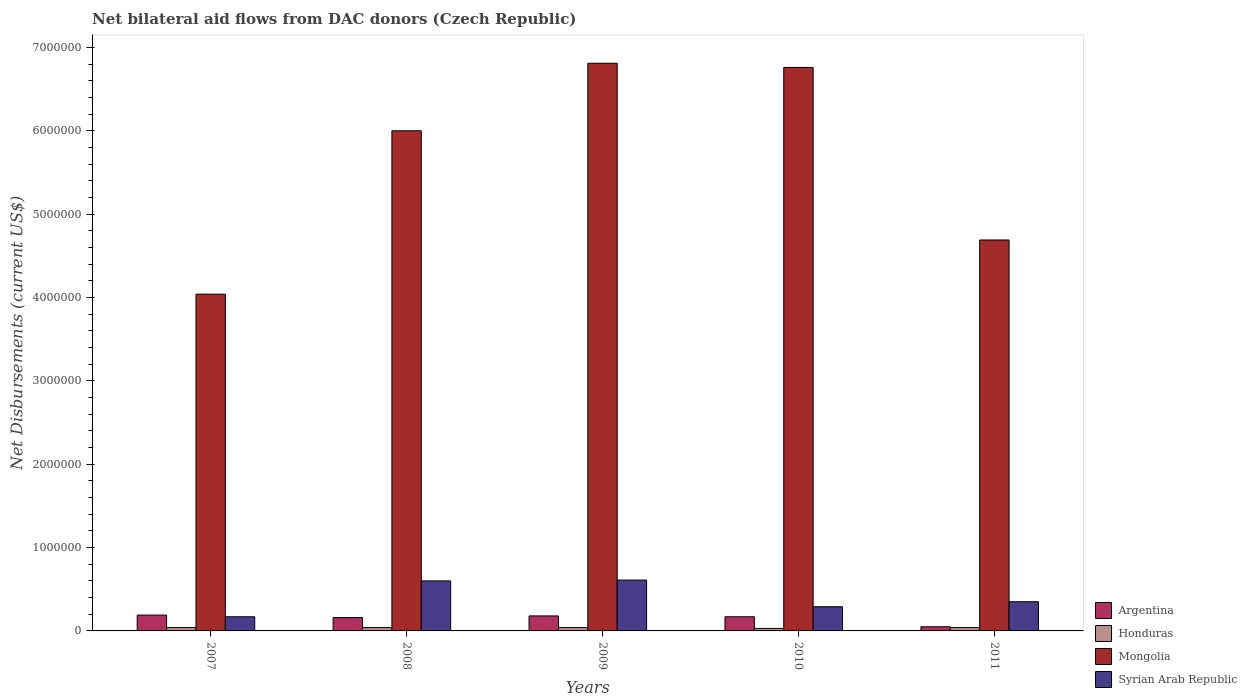How many different coloured bars are there?
Offer a very short reply. 4. Are the number of bars on each tick of the X-axis equal?
Ensure brevity in your answer.  Yes. How many bars are there on the 4th tick from the left?
Keep it short and to the point. 4. How many bars are there on the 2nd tick from the right?
Your answer should be compact. 4. What is the label of the 4th group of bars from the left?
Provide a succinct answer. 2010. In how many cases, is the number of bars for a given year not equal to the number of legend labels?
Give a very brief answer. 0. What is the net bilateral aid flows in Mongolia in 2010?
Make the answer very short. 6.76e+06. Across all years, what is the maximum net bilateral aid flows in Syrian Arab Republic?
Provide a short and direct response. 6.10e+05. Across all years, what is the minimum net bilateral aid flows in Honduras?
Make the answer very short. 3.00e+04. In which year was the net bilateral aid flows in Argentina minimum?
Your response must be concise. 2011. What is the total net bilateral aid flows in Syrian Arab Republic in the graph?
Your answer should be very brief. 2.02e+06. What is the difference between the net bilateral aid flows in Argentina in 2007 and that in 2011?
Give a very brief answer. 1.40e+05. What is the difference between the net bilateral aid flows in Mongolia in 2010 and the net bilateral aid flows in Honduras in 2009?
Your answer should be compact. 6.72e+06. What is the average net bilateral aid flows in Syrian Arab Republic per year?
Ensure brevity in your answer.  4.04e+05. In the year 2010, what is the difference between the net bilateral aid flows in Mongolia and net bilateral aid flows in Syrian Arab Republic?
Provide a succinct answer. 6.47e+06. In how many years, is the net bilateral aid flows in Mongolia greater than 2400000 US$?
Your response must be concise. 5. What is the ratio of the net bilateral aid flows in Honduras in 2008 to that in 2011?
Give a very brief answer. 1. Is the net bilateral aid flows in Argentina in 2007 less than that in 2009?
Ensure brevity in your answer.  No. What is the difference between the highest and the lowest net bilateral aid flows in Syrian Arab Republic?
Offer a very short reply. 4.40e+05. What does the 4th bar from the left in 2010 represents?
Provide a succinct answer. Syrian Arab Republic. What does the 2nd bar from the right in 2011 represents?
Give a very brief answer. Mongolia. How many bars are there?
Keep it short and to the point. 20. Are all the bars in the graph horizontal?
Provide a short and direct response. No. How many years are there in the graph?
Offer a terse response. 5. What is the difference between two consecutive major ticks on the Y-axis?
Ensure brevity in your answer.  1.00e+06. Does the graph contain grids?
Make the answer very short. No. How many legend labels are there?
Ensure brevity in your answer.  4. What is the title of the graph?
Provide a succinct answer. Net bilateral aid flows from DAC donors (Czech Republic). Does "Middle East & North Africa (developing only)" appear as one of the legend labels in the graph?
Keep it short and to the point. No. What is the label or title of the X-axis?
Your answer should be compact. Years. What is the label or title of the Y-axis?
Your answer should be compact. Net Disbursements (current US$). What is the Net Disbursements (current US$) in Argentina in 2007?
Make the answer very short. 1.90e+05. What is the Net Disbursements (current US$) in Mongolia in 2007?
Give a very brief answer. 4.04e+06. What is the Net Disbursements (current US$) of Syrian Arab Republic in 2007?
Offer a terse response. 1.70e+05. What is the Net Disbursements (current US$) in Argentina in 2008?
Ensure brevity in your answer.  1.60e+05. What is the Net Disbursements (current US$) of Honduras in 2009?
Give a very brief answer. 4.00e+04. What is the Net Disbursements (current US$) of Mongolia in 2009?
Your answer should be compact. 6.81e+06. What is the Net Disbursements (current US$) in Syrian Arab Republic in 2009?
Provide a succinct answer. 6.10e+05. What is the Net Disbursements (current US$) of Argentina in 2010?
Give a very brief answer. 1.70e+05. What is the Net Disbursements (current US$) in Mongolia in 2010?
Offer a very short reply. 6.76e+06. What is the Net Disbursements (current US$) in Syrian Arab Republic in 2010?
Provide a succinct answer. 2.90e+05. What is the Net Disbursements (current US$) of Mongolia in 2011?
Provide a succinct answer. 4.69e+06. What is the Net Disbursements (current US$) of Syrian Arab Republic in 2011?
Offer a very short reply. 3.50e+05. Across all years, what is the maximum Net Disbursements (current US$) of Mongolia?
Your response must be concise. 6.81e+06. Across all years, what is the minimum Net Disbursements (current US$) in Argentina?
Offer a terse response. 5.00e+04. Across all years, what is the minimum Net Disbursements (current US$) of Mongolia?
Keep it short and to the point. 4.04e+06. Across all years, what is the minimum Net Disbursements (current US$) of Syrian Arab Republic?
Make the answer very short. 1.70e+05. What is the total Net Disbursements (current US$) in Argentina in the graph?
Your response must be concise. 7.50e+05. What is the total Net Disbursements (current US$) of Mongolia in the graph?
Your answer should be compact. 2.83e+07. What is the total Net Disbursements (current US$) in Syrian Arab Republic in the graph?
Offer a terse response. 2.02e+06. What is the difference between the Net Disbursements (current US$) of Argentina in 2007 and that in 2008?
Your answer should be compact. 3.00e+04. What is the difference between the Net Disbursements (current US$) in Honduras in 2007 and that in 2008?
Provide a succinct answer. 0. What is the difference between the Net Disbursements (current US$) of Mongolia in 2007 and that in 2008?
Your answer should be compact. -1.96e+06. What is the difference between the Net Disbursements (current US$) in Syrian Arab Republic in 2007 and that in 2008?
Keep it short and to the point. -4.30e+05. What is the difference between the Net Disbursements (current US$) in Honduras in 2007 and that in 2009?
Keep it short and to the point. 0. What is the difference between the Net Disbursements (current US$) in Mongolia in 2007 and that in 2009?
Give a very brief answer. -2.77e+06. What is the difference between the Net Disbursements (current US$) in Syrian Arab Republic in 2007 and that in 2009?
Give a very brief answer. -4.40e+05. What is the difference between the Net Disbursements (current US$) of Mongolia in 2007 and that in 2010?
Provide a short and direct response. -2.72e+06. What is the difference between the Net Disbursements (current US$) of Argentina in 2007 and that in 2011?
Provide a short and direct response. 1.40e+05. What is the difference between the Net Disbursements (current US$) in Honduras in 2007 and that in 2011?
Provide a short and direct response. 0. What is the difference between the Net Disbursements (current US$) in Mongolia in 2007 and that in 2011?
Ensure brevity in your answer.  -6.50e+05. What is the difference between the Net Disbursements (current US$) of Argentina in 2008 and that in 2009?
Your response must be concise. -2.00e+04. What is the difference between the Net Disbursements (current US$) of Mongolia in 2008 and that in 2009?
Your answer should be compact. -8.10e+05. What is the difference between the Net Disbursements (current US$) in Mongolia in 2008 and that in 2010?
Your answer should be compact. -7.60e+05. What is the difference between the Net Disbursements (current US$) in Mongolia in 2008 and that in 2011?
Provide a succinct answer. 1.31e+06. What is the difference between the Net Disbursements (current US$) of Honduras in 2009 and that in 2010?
Offer a terse response. 10000. What is the difference between the Net Disbursements (current US$) of Mongolia in 2009 and that in 2010?
Your answer should be compact. 5.00e+04. What is the difference between the Net Disbursements (current US$) in Syrian Arab Republic in 2009 and that in 2010?
Give a very brief answer. 3.20e+05. What is the difference between the Net Disbursements (current US$) in Honduras in 2009 and that in 2011?
Make the answer very short. 0. What is the difference between the Net Disbursements (current US$) in Mongolia in 2009 and that in 2011?
Your answer should be compact. 2.12e+06. What is the difference between the Net Disbursements (current US$) of Syrian Arab Republic in 2009 and that in 2011?
Make the answer very short. 2.60e+05. What is the difference between the Net Disbursements (current US$) in Honduras in 2010 and that in 2011?
Offer a terse response. -10000. What is the difference between the Net Disbursements (current US$) in Mongolia in 2010 and that in 2011?
Provide a short and direct response. 2.07e+06. What is the difference between the Net Disbursements (current US$) of Syrian Arab Republic in 2010 and that in 2011?
Provide a short and direct response. -6.00e+04. What is the difference between the Net Disbursements (current US$) in Argentina in 2007 and the Net Disbursements (current US$) in Honduras in 2008?
Offer a terse response. 1.50e+05. What is the difference between the Net Disbursements (current US$) of Argentina in 2007 and the Net Disbursements (current US$) of Mongolia in 2008?
Provide a short and direct response. -5.81e+06. What is the difference between the Net Disbursements (current US$) of Argentina in 2007 and the Net Disbursements (current US$) of Syrian Arab Republic in 2008?
Provide a succinct answer. -4.10e+05. What is the difference between the Net Disbursements (current US$) in Honduras in 2007 and the Net Disbursements (current US$) in Mongolia in 2008?
Offer a terse response. -5.96e+06. What is the difference between the Net Disbursements (current US$) of Honduras in 2007 and the Net Disbursements (current US$) of Syrian Arab Republic in 2008?
Your answer should be very brief. -5.60e+05. What is the difference between the Net Disbursements (current US$) in Mongolia in 2007 and the Net Disbursements (current US$) in Syrian Arab Republic in 2008?
Keep it short and to the point. 3.44e+06. What is the difference between the Net Disbursements (current US$) in Argentina in 2007 and the Net Disbursements (current US$) in Mongolia in 2009?
Offer a very short reply. -6.62e+06. What is the difference between the Net Disbursements (current US$) in Argentina in 2007 and the Net Disbursements (current US$) in Syrian Arab Republic in 2009?
Offer a terse response. -4.20e+05. What is the difference between the Net Disbursements (current US$) of Honduras in 2007 and the Net Disbursements (current US$) of Mongolia in 2009?
Your answer should be very brief. -6.77e+06. What is the difference between the Net Disbursements (current US$) in Honduras in 2007 and the Net Disbursements (current US$) in Syrian Arab Republic in 2009?
Provide a short and direct response. -5.70e+05. What is the difference between the Net Disbursements (current US$) in Mongolia in 2007 and the Net Disbursements (current US$) in Syrian Arab Republic in 2009?
Your response must be concise. 3.43e+06. What is the difference between the Net Disbursements (current US$) in Argentina in 2007 and the Net Disbursements (current US$) in Mongolia in 2010?
Your response must be concise. -6.57e+06. What is the difference between the Net Disbursements (current US$) of Honduras in 2007 and the Net Disbursements (current US$) of Mongolia in 2010?
Keep it short and to the point. -6.72e+06. What is the difference between the Net Disbursements (current US$) of Honduras in 2007 and the Net Disbursements (current US$) of Syrian Arab Republic in 2010?
Give a very brief answer. -2.50e+05. What is the difference between the Net Disbursements (current US$) of Mongolia in 2007 and the Net Disbursements (current US$) of Syrian Arab Republic in 2010?
Keep it short and to the point. 3.75e+06. What is the difference between the Net Disbursements (current US$) in Argentina in 2007 and the Net Disbursements (current US$) in Mongolia in 2011?
Your response must be concise. -4.50e+06. What is the difference between the Net Disbursements (current US$) of Honduras in 2007 and the Net Disbursements (current US$) of Mongolia in 2011?
Offer a very short reply. -4.65e+06. What is the difference between the Net Disbursements (current US$) in Honduras in 2007 and the Net Disbursements (current US$) in Syrian Arab Republic in 2011?
Make the answer very short. -3.10e+05. What is the difference between the Net Disbursements (current US$) in Mongolia in 2007 and the Net Disbursements (current US$) in Syrian Arab Republic in 2011?
Give a very brief answer. 3.69e+06. What is the difference between the Net Disbursements (current US$) of Argentina in 2008 and the Net Disbursements (current US$) of Honduras in 2009?
Your response must be concise. 1.20e+05. What is the difference between the Net Disbursements (current US$) in Argentina in 2008 and the Net Disbursements (current US$) in Mongolia in 2009?
Offer a very short reply. -6.65e+06. What is the difference between the Net Disbursements (current US$) of Argentina in 2008 and the Net Disbursements (current US$) of Syrian Arab Republic in 2009?
Give a very brief answer. -4.50e+05. What is the difference between the Net Disbursements (current US$) of Honduras in 2008 and the Net Disbursements (current US$) of Mongolia in 2009?
Your answer should be compact. -6.77e+06. What is the difference between the Net Disbursements (current US$) in Honduras in 2008 and the Net Disbursements (current US$) in Syrian Arab Republic in 2009?
Keep it short and to the point. -5.70e+05. What is the difference between the Net Disbursements (current US$) in Mongolia in 2008 and the Net Disbursements (current US$) in Syrian Arab Republic in 2009?
Ensure brevity in your answer.  5.39e+06. What is the difference between the Net Disbursements (current US$) in Argentina in 2008 and the Net Disbursements (current US$) in Honduras in 2010?
Offer a very short reply. 1.30e+05. What is the difference between the Net Disbursements (current US$) in Argentina in 2008 and the Net Disbursements (current US$) in Mongolia in 2010?
Provide a succinct answer. -6.60e+06. What is the difference between the Net Disbursements (current US$) in Honduras in 2008 and the Net Disbursements (current US$) in Mongolia in 2010?
Your response must be concise. -6.72e+06. What is the difference between the Net Disbursements (current US$) of Mongolia in 2008 and the Net Disbursements (current US$) of Syrian Arab Republic in 2010?
Give a very brief answer. 5.71e+06. What is the difference between the Net Disbursements (current US$) in Argentina in 2008 and the Net Disbursements (current US$) in Honduras in 2011?
Offer a terse response. 1.20e+05. What is the difference between the Net Disbursements (current US$) in Argentina in 2008 and the Net Disbursements (current US$) in Mongolia in 2011?
Make the answer very short. -4.53e+06. What is the difference between the Net Disbursements (current US$) of Honduras in 2008 and the Net Disbursements (current US$) of Mongolia in 2011?
Your answer should be very brief. -4.65e+06. What is the difference between the Net Disbursements (current US$) in Honduras in 2008 and the Net Disbursements (current US$) in Syrian Arab Republic in 2011?
Offer a terse response. -3.10e+05. What is the difference between the Net Disbursements (current US$) in Mongolia in 2008 and the Net Disbursements (current US$) in Syrian Arab Republic in 2011?
Provide a short and direct response. 5.65e+06. What is the difference between the Net Disbursements (current US$) of Argentina in 2009 and the Net Disbursements (current US$) of Honduras in 2010?
Ensure brevity in your answer.  1.50e+05. What is the difference between the Net Disbursements (current US$) of Argentina in 2009 and the Net Disbursements (current US$) of Mongolia in 2010?
Your answer should be very brief. -6.58e+06. What is the difference between the Net Disbursements (current US$) in Argentina in 2009 and the Net Disbursements (current US$) in Syrian Arab Republic in 2010?
Offer a terse response. -1.10e+05. What is the difference between the Net Disbursements (current US$) of Honduras in 2009 and the Net Disbursements (current US$) of Mongolia in 2010?
Your answer should be compact. -6.72e+06. What is the difference between the Net Disbursements (current US$) of Honduras in 2009 and the Net Disbursements (current US$) of Syrian Arab Republic in 2010?
Provide a short and direct response. -2.50e+05. What is the difference between the Net Disbursements (current US$) in Mongolia in 2009 and the Net Disbursements (current US$) in Syrian Arab Republic in 2010?
Give a very brief answer. 6.52e+06. What is the difference between the Net Disbursements (current US$) of Argentina in 2009 and the Net Disbursements (current US$) of Honduras in 2011?
Your response must be concise. 1.40e+05. What is the difference between the Net Disbursements (current US$) of Argentina in 2009 and the Net Disbursements (current US$) of Mongolia in 2011?
Make the answer very short. -4.51e+06. What is the difference between the Net Disbursements (current US$) of Argentina in 2009 and the Net Disbursements (current US$) of Syrian Arab Republic in 2011?
Keep it short and to the point. -1.70e+05. What is the difference between the Net Disbursements (current US$) in Honduras in 2009 and the Net Disbursements (current US$) in Mongolia in 2011?
Your answer should be compact. -4.65e+06. What is the difference between the Net Disbursements (current US$) of Honduras in 2009 and the Net Disbursements (current US$) of Syrian Arab Republic in 2011?
Give a very brief answer. -3.10e+05. What is the difference between the Net Disbursements (current US$) of Mongolia in 2009 and the Net Disbursements (current US$) of Syrian Arab Republic in 2011?
Your response must be concise. 6.46e+06. What is the difference between the Net Disbursements (current US$) in Argentina in 2010 and the Net Disbursements (current US$) in Mongolia in 2011?
Your answer should be compact. -4.52e+06. What is the difference between the Net Disbursements (current US$) in Argentina in 2010 and the Net Disbursements (current US$) in Syrian Arab Republic in 2011?
Keep it short and to the point. -1.80e+05. What is the difference between the Net Disbursements (current US$) of Honduras in 2010 and the Net Disbursements (current US$) of Mongolia in 2011?
Ensure brevity in your answer.  -4.66e+06. What is the difference between the Net Disbursements (current US$) of Honduras in 2010 and the Net Disbursements (current US$) of Syrian Arab Republic in 2011?
Make the answer very short. -3.20e+05. What is the difference between the Net Disbursements (current US$) of Mongolia in 2010 and the Net Disbursements (current US$) of Syrian Arab Republic in 2011?
Offer a terse response. 6.41e+06. What is the average Net Disbursements (current US$) in Argentina per year?
Give a very brief answer. 1.50e+05. What is the average Net Disbursements (current US$) of Honduras per year?
Offer a very short reply. 3.80e+04. What is the average Net Disbursements (current US$) of Mongolia per year?
Provide a short and direct response. 5.66e+06. What is the average Net Disbursements (current US$) of Syrian Arab Republic per year?
Keep it short and to the point. 4.04e+05. In the year 2007, what is the difference between the Net Disbursements (current US$) in Argentina and Net Disbursements (current US$) in Honduras?
Your answer should be very brief. 1.50e+05. In the year 2007, what is the difference between the Net Disbursements (current US$) of Argentina and Net Disbursements (current US$) of Mongolia?
Your answer should be very brief. -3.85e+06. In the year 2007, what is the difference between the Net Disbursements (current US$) of Honduras and Net Disbursements (current US$) of Mongolia?
Give a very brief answer. -4.00e+06. In the year 2007, what is the difference between the Net Disbursements (current US$) in Honduras and Net Disbursements (current US$) in Syrian Arab Republic?
Keep it short and to the point. -1.30e+05. In the year 2007, what is the difference between the Net Disbursements (current US$) in Mongolia and Net Disbursements (current US$) in Syrian Arab Republic?
Provide a short and direct response. 3.87e+06. In the year 2008, what is the difference between the Net Disbursements (current US$) of Argentina and Net Disbursements (current US$) of Mongolia?
Provide a succinct answer. -5.84e+06. In the year 2008, what is the difference between the Net Disbursements (current US$) in Argentina and Net Disbursements (current US$) in Syrian Arab Republic?
Offer a very short reply. -4.40e+05. In the year 2008, what is the difference between the Net Disbursements (current US$) of Honduras and Net Disbursements (current US$) of Mongolia?
Provide a short and direct response. -5.96e+06. In the year 2008, what is the difference between the Net Disbursements (current US$) in Honduras and Net Disbursements (current US$) in Syrian Arab Republic?
Give a very brief answer. -5.60e+05. In the year 2008, what is the difference between the Net Disbursements (current US$) in Mongolia and Net Disbursements (current US$) in Syrian Arab Republic?
Keep it short and to the point. 5.40e+06. In the year 2009, what is the difference between the Net Disbursements (current US$) in Argentina and Net Disbursements (current US$) in Honduras?
Your answer should be very brief. 1.40e+05. In the year 2009, what is the difference between the Net Disbursements (current US$) in Argentina and Net Disbursements (current US$) in Mongolia?
Your answer should be compact. -6.63e+06. In the year 2009, what is the difference between the Net Disbursements (current US$) in Argentina and Net Disbursements (current US$) in Syrian Arab Republic?
Keep it short and to the point. -4.30e+05. In the year 2009, what is the difference between the Net Disbursements (current US$) in Honduras and Net Disbursements (current US$) in Mongolia?
Your answer should be very brief. -6.77e+06. In the year 2009, what is the difference between the Net Disbursements (current US$) in Honduras and Net Disbursements (current US$) in Syrian Arab Republic?
Offer a very short reply. -5.70e+05. In the year 2009, what is the difference between the Net Disbursements (current US$) of Mongolia and Net Disbursements (current US$) of Syrian Arab Republic?
Make the answer very short. 6.20e+06. In the year 2010, what is the difference between the Net Disbursements (current US$) in Argentina and Net Disbursements (current US$) in Honduras?
Provide a succinct answer. 1.40e+05. In the year 2010, what is the difference between the Net Disbursements (current US$) of Argentina and Net Disbursements (current US$) of Mongolia?
Keep it short and to the point. -6.59e+06. In the year 2010, what is the difference between the Net Disbursements (current US$) in Argentina and Net Disbursements (current US$) in Syrian Arab Republic?
Make the answer very short. -1.20e+05. In the year 2010, what is the difference between the Net Disbursements (current US$) of Honduras and Net Disbursements (current US$) of Mongolia?
Provide a short and direct response. -6.73e+06. In the year 2010, what is the difference between the Net Disbursements (current US$) in Honduras and Net Disbursements (current US$) in Syrian Arab Republic?
Offer a terse response. -2.60e+05. In the year 2010, what is the difference between the Net Disbursements (current US$) in Mongolia and Net Disbursements (current US$) in Syrian Arab Republic?
Offer a very short reply. 6.47e+06. In the year 2011, what is the difference between the Net Disbursements (current US$) in Argentina and Net Disbursements (current US$) in Honduras?
Your answer should be compact. 10000. In the year 2011, what is the difference between the Net Disbursements (current US$) of Argentina and Net Disbursements (current US$) of Mongolia?
Your response must be concise. -4.64e+06. In the year 2011, what is the difference between the Net Disbursements (current US$) in Honduras and Net Disbursements (current US$) in Mongolia?
Make the answer very short. -4.65e+06. In the year 2011, what is the difference between the Net Disbursements (current US$) of Honduras and Net Disbursements (current US$) of Syrian Arab Republic?
Give a very brief answer. -3.10e+05. In the year 2011, what is the difference between the Net Disbursements (current US$) of Mongolia and Net Disbursements (current US$) of Syrian Arab Republic?
Give a very brief answer. 4.34e+06. What is the ratio of the Net Disbursements (current US$) in Argentina in 2007 to that in 2008?
Ensure brevity in your answer.  1.19. What is the ratio of the Net Disbursements (current US$) of Mongolia in 2007 to that in 2008?
Keep it short and to the point. 0.67. What is the ratio of the Net Disbursements (current US$) of Syrian Arab Republic in 2007 to that in 2008?
Provide a short and direct response. 0.28. What is the ratio of the Net Disbursements (current US$) of Argentina in 2007 to that in 2009?
Offer a very short reply. 1.06. What is the ratio of the Net Disbursements (current US$) of Mongolia in 2007 to that in 2009?
Keep it short and to the point. 0.59. What is the ratio of the Net Disbursements (current US$) in Syrian Arab Republic in 2007 to that in 2009?
Ensure brevity in your answer.  0.28. What is the ratio of the Net Disbursements (current US$) of Argentina in 2007 to that in 2010?
Provide a succinct answer. 1.12. What is the ratio of the Net Disbursements (current US$) of Honduras in 2007 to that in 2010?
Your answer should be compact. 1.33. What is the ratio of the Net Disbursements (current US$) in Mongolia in 2007 to that in 2010?
Give a very brief answer. 0.6. What is the ratio of the Net Disbursements (current US$) of Syrian Arab Republic in 2007 to that in 2010?
Ensure brevity in your answer.  0.59. What is the ratio of the Net Disbursements (current US$) in Argentina in 2007 to that in 2011?
Make the answer very short. 3.8. What is the ratio of the Net Disbursements (current US$) of Mongolia in 2007 to that in 2011?
Provide a succinct answer. 0.86. What is the ratio of the Net Disbursements (current US$) of Syrian Arab Republic in 2007 to that in 2011?
Offer a terse response. 0.49. What is the ratio of the Net Disbursements (current US$) in Mongolia in 2008 to that in 2009?
Provide a short and direct response. 0.88. What is the ratio of the Net Disbursements (current US$) in Syrian Arab Republic in 2008 to that in 2009?
Your response must be concise. 0.98. What is the ratio of the Net Disbursements (current US$) of Argentina in 2008 to that in 2010?
Ensure brevity in your answer.  0.94. What is the ratio of the Net Disbursements (current US$) in Mongolia in 2008 to that in 2010?
Provide a succinct answer. 0.89. What is the ratio of the Net Disbursements (current US$) in Syrian Arab Republic in 2008 to that in 2010?
Provide a succinct answer. 2.07. What is the ratio of the Net Disbursements (current US$) in Honduras in 2008 to that in 2011?
Your answer should be very brief. 1. What is the ratio of the Net Disbursements (current US$) in Mongolia in 2008 to that in 2011?
Offer a very short reply. 1.28. What is the ratio of the Net Disbursements (current US$) in Syrian Arab Republic in 2008 to that in 2011?
Ensure brevity in your answer.  1.71. What is the ratio of the Net Disbursements (current US$) in Argentina in 2009 to that in 2010?
Provide a succinct answer. 1.06. What is the ratio of the Net Disbursements (current US$) in Mongolia in 2009 to that in 2010?
Your answer should be compact. 1.01. What is the ratio of the Net Disbursements (current US$) of Syrian Arab Republic in 2009 to that in 2010?
Offer a very short reply. 2.1. What is the ratio of the Net Disbursements (current US$) in Mongolia in 2009 to that in 2011?
Make the answer very short. 1.45. What is the ratio of the Net Disbursements (current US$) of Syrian Arab Republic in 2009 to that in 2011?
Ensure brevity in your answer.  1.74. What is the ratio of the Net Disbursements (current US$) in Argentina in 2010 to that in 2011?
Provide a succinct answer. 3.4. What is the ratio of the Net Disbursements (current US$) of Mongolia in 2010 to that in 2011?
Provide a short and direct response. 1.44. What is the ratio of the Net Disbursements (current US$) in Syrian Arab Republic in 2010 to that in 2011?
Give a very brief answer. 0.83. What is the difference between the highest and the second highest Net Disbursements (current US$) in Mongolia?
Ensure brevity in your answer.  5.00e+04. What is the difference between the highest and the lowest Net Disbursements (current US$) of Honduras?
Your response must be concise. 10000. What is the difference between the highest and the lowest Net Disbursements (current US$) in Mongolia?
Provide a succinct answer. 2.77e+06. 